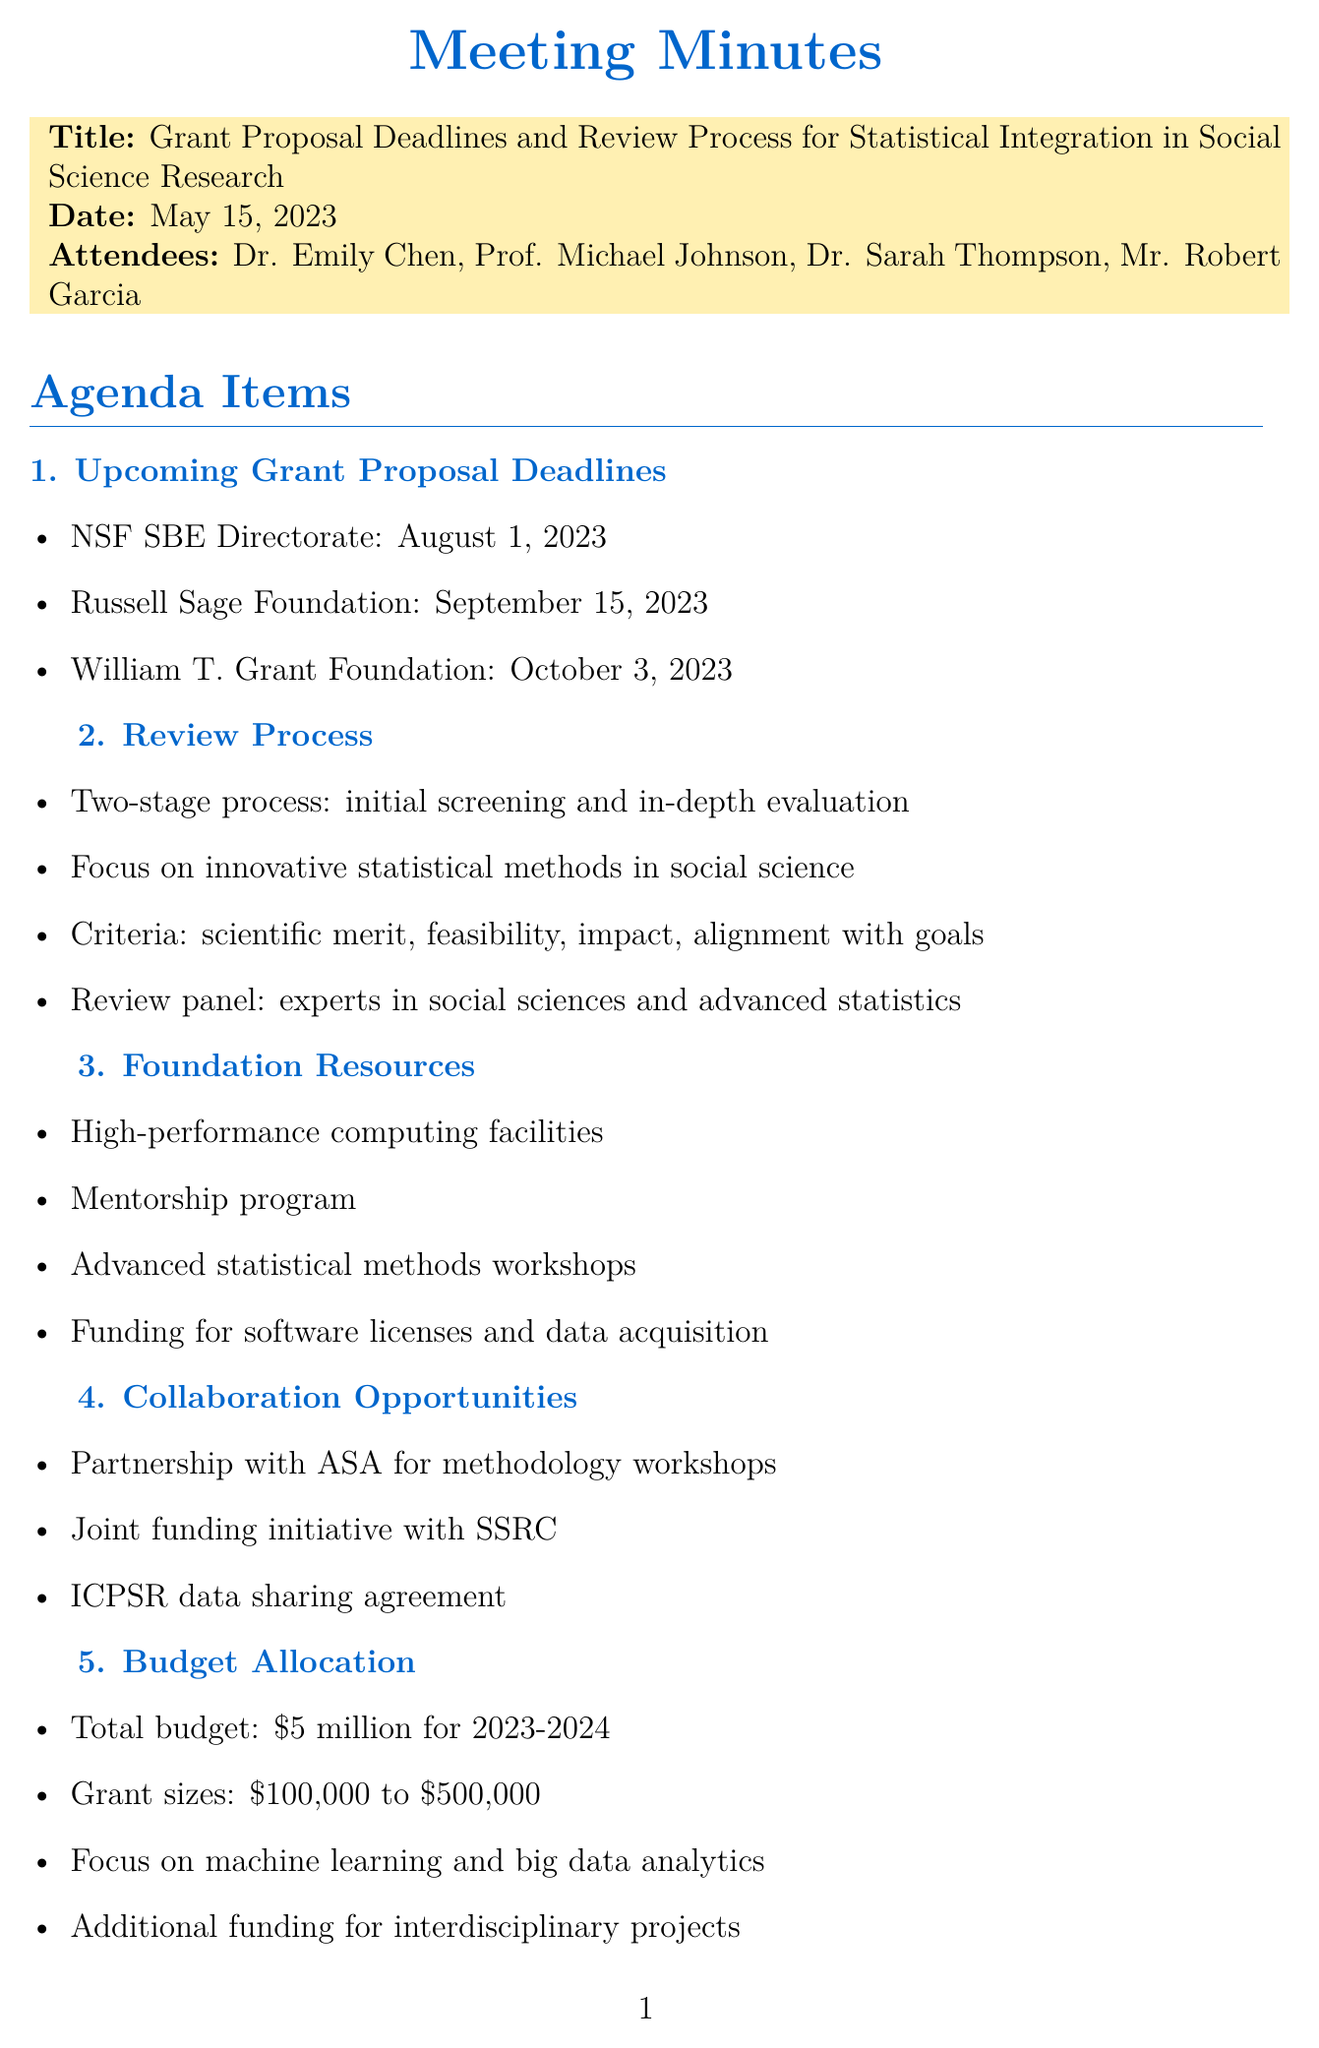what is the date of the meeting? The date of the meeting is explicitly mentioned in the document as May 15, 2023.
Answer: May 15, 2023 who is the Grants Administrator? The document lists attendees, and Mr. Robert Garcia is identified as the Grants Administrator.
Answer: Mr. Robert Garcia what is the deadline for the NSF SBE Directorate? The deadline for the NSF SBE Directorate is specified in the agenda items details section.
Answer: August 1, 2023 how much total budget is allocated for fiscal year 2023-2024? The total budget allocation for the fiscal year 2023-2024 is clearly stated in the budget allocation section.
Answer: five million dollars what are the criteria for evaluating proposals? The evaluation criteria for proposals are listed in the review process section of the document.
Answer: scientific merit, feasibility, potential impact, and alignment with foundation goals who will organize the information session for potential applicants? The action items section mentions that Prof. Michael Johnson is responsible for organizing the information session.
Answer: Prof. Michael Johnson when is the next meeting scheduled? The next meeting date is provided at the end of the document, detailing when it will occur.
Answer: June 30, 2023 what resources are offered by the foundation? The foundation resources are enumerated in one of the agenda items discussing what support is provided.
Answer: high-performance computing facilities, mentorship program, workshops, funding for software licenses and data acquisition which collaborative partnership is mentioned for methodology workshops? The document outlines collaboration opportunities, explicitly mentioning a partnership for methodology workshops.
Answer: American Statistical Association (ASA) 